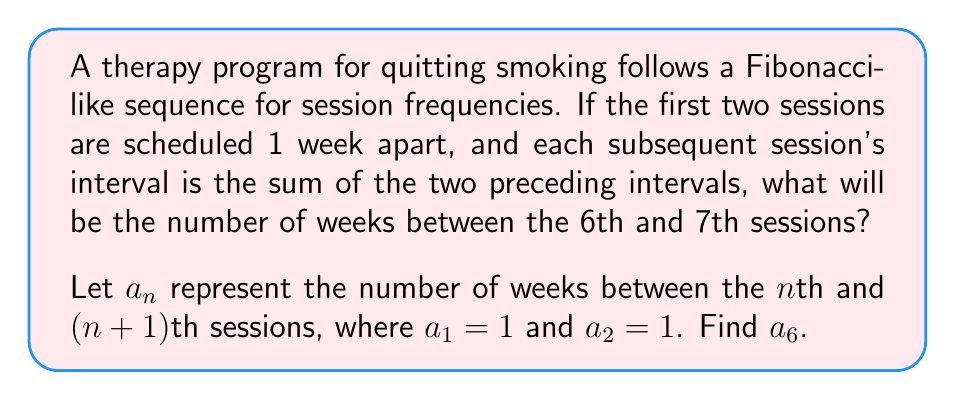Help me with this question. To solve this problem, we need to follow these steps:

1) First, let's write out the Fibonacci-like sequence for the first few terms:

   $a_1 = 1$ (1 week between 1st and 2nd sessions)
   $a_2 = 1$ (1 week between 2nd and 3rd sessions)

2) Now, we calculate the subsequent terms using the rule $a_n = a_{n-1} + a_{n-2}$:

   $a_3 = a_2 + a_1 = 1 + 1 = 2$ (2 weeks between 3rd and 4th sessions)
   $a_4 = a_3 + a_2 = 2 + 1 = 3$ (3 weeks between 4th and 5th sessions)
   $a_5 = a_4 + a_3 = 3 + 2 = 5$ (5 weeks between 5th and 6th sessions)
   $a_6 = a_5 + a_4 = 5 + 3 = 8$ (8 weeks between 6th and 7th sessions)

3) Therefore, the number of weeks between the 6th and 7th sessions is 8.

This sequence mimics the gradual reduction in therapy frequency that might be used in a smoking cessation program, allowing for longer intervals between sessions as the ex-smoker becomes more confident in their ability to stay smoke-free.
Answer: 8 weeks 